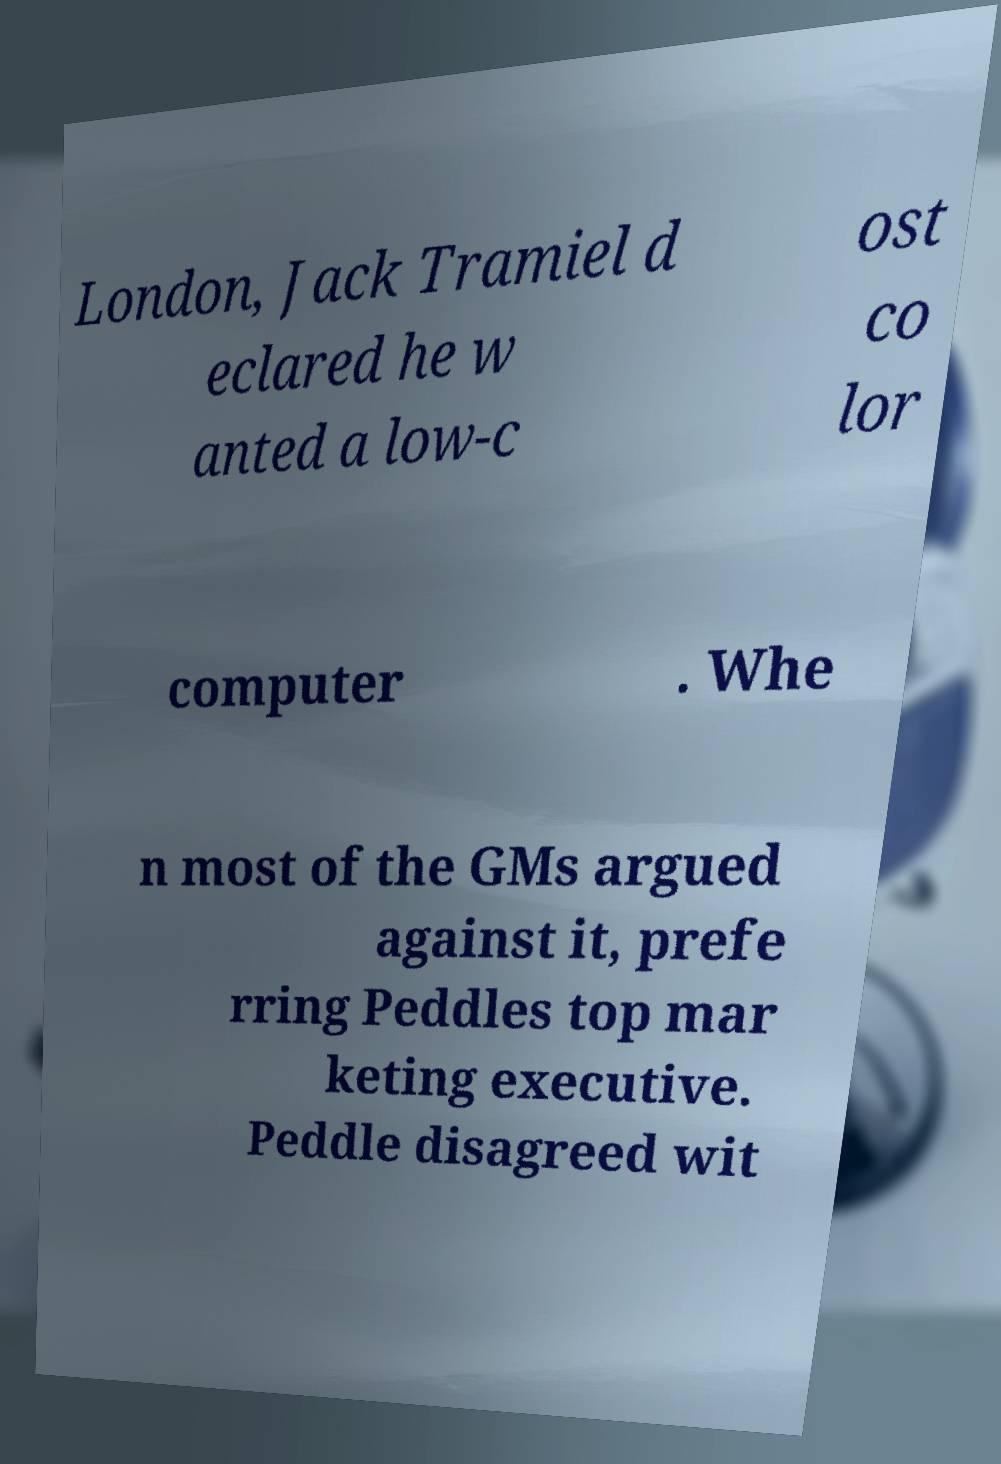Please identify and transcribe the text found in this image. London, Jack Tramiel d eclared he w anted a low-c ost co lor computer . Whe n most of the GMs argued against it, prefe rring Peddles top mar keting executive. Peddle disagreed wit 